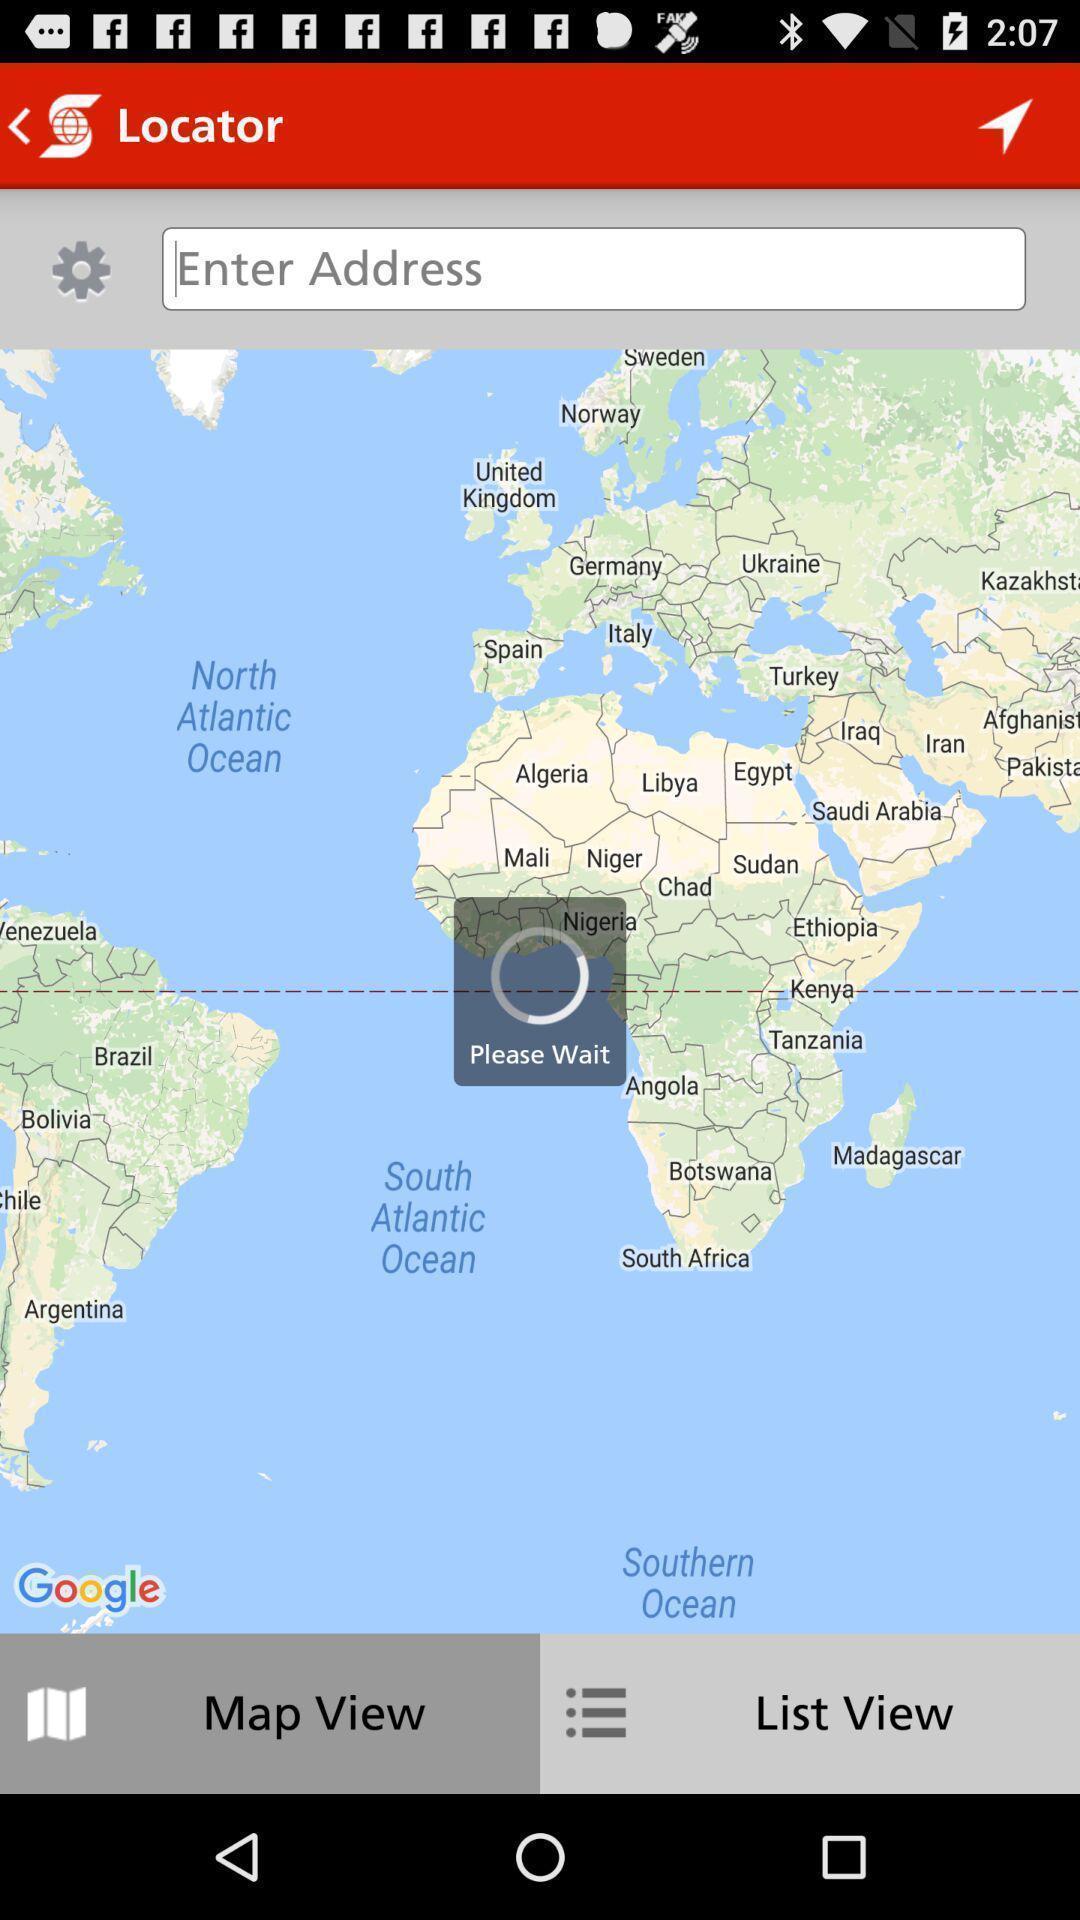Tell me about the visual elements in this screen capture. Screen displaying a map view and a loading icon. 